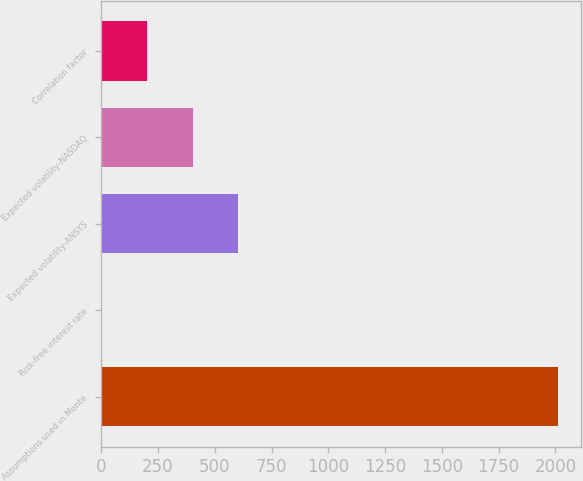Convert chart to OTSL. <chart><loc_0><loc_0><loc_500><loc_500><bar_chart><fcel>Assumptions used in Monte<fcel>Risk-free interest rate<fcel>Expected volatility-ANSYS<fcel>Expected volatility-NASDAQ<fcel>Correlation factor<nl><fcel>2013<fcel>0.35<fcel>604.14<fcel>402.88<fcel>201.62<nl></chart> 